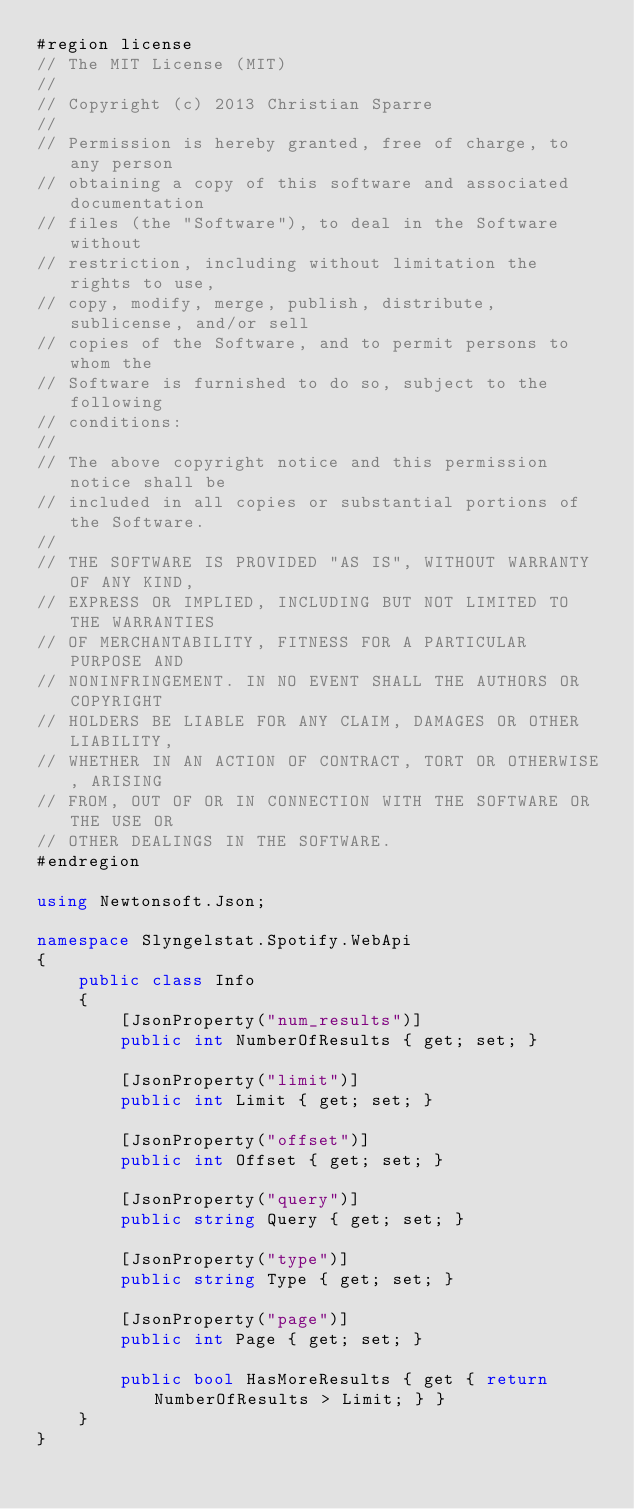Convert code to text. <code><loc_0><loc_0><loc_500><loc_500><_C#_>#region license
// The MIT License (MIT)
//
// Copyright (c) 2013 Christian Sparre
//
// Permission is hereby granted, free of charge, to any person
// obtaining a copy of this software and associated documentation
// files (the "Software"), to deal in the Software without
// restriction, including without limitation the rights to use,
// copy, modify, merge, publish, distribute, sublicense, and/or sell
// copies of the Software, and to permit persons to whom the
// Software is furnished to do so, subject to the following
// conditions:
//
// The above copyright notice and this permission notice shall be
// included in all copies or substantial portions of the Software.
//
// THE SOFTWARE IS PROVIDED "AS IS", WITHOUT WARRANTY OF ANY KIND,
// EXPRESS OR IMPLIED, INCLUDING BUT NOT LIMITED TO THE WARRANTIES
// OF MERCHANTABILITY, FITNESS FOR A PARTICULAR PURPOSE AND
// NONINFRINGEMENT. IN NO EVENT SHALL THE AUTHORS OR COPYRIGHT
// HOLDERS BE LIABLE FOR ANY CLAIM, DAMAGES OR OTHER LIABILITY,
// WHETHER IN AN ACTION OF CONTRACT, TORT OR OTHERWISE, ARISING
// FROM, OUT OF OR IN CONNECTION WITH THE SOFTWARE OR THE USE OR
// OTHER DEALINGS IN THE SOFTWARE.
#endregion

using Newtonsoft.Json;

namespace Slyngelstat.Spotify.WebApi
{
    public class Info
    {
        [JsonProperty("num_results")]
        public int NumberOfResults { get; set; }

        [JsonProperty("limit")]
        public int Limit { get; set; }

        [JsonProperty("offset")]
        public int Offset { get; set; }

        [JsonProperty("query")]
        public string Query { get; set; }

        [JsonProperty("type")]
        public string Type { get; set; }

        [JsonProperty("page")]
        public int Page { get; set; }

        public bool HasMoreResults { get { return NumberOfResults > Limit; } }
    }
}</code> 